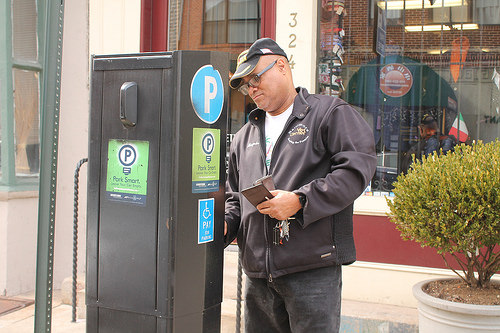<image>
Is the man behind the parking meter? Yes. From this viewpoint, the man is positioned behind the parking meter, with the parking meter partially or fully occluding the man. Is the flag in the window? Yes. The flag is contained within or inside the window, showing a containment relationship. 